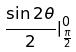<formula> <loc_0><loc_0><loc_500><loc_500>\frac { \sin 2 \theta } { 2 } | _ { \frac { \pi } { 2 } } ^ { 0 }</formula> 